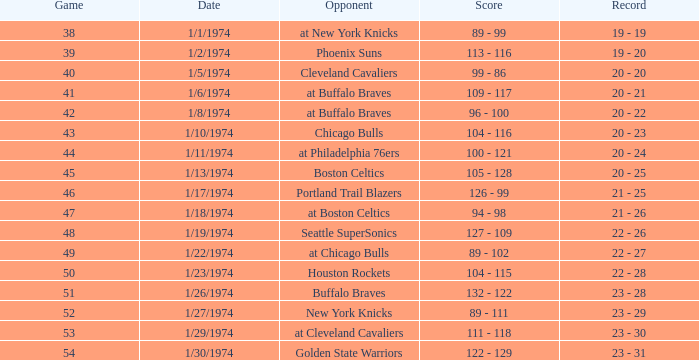What was the result on the 10th of january, 1974? 104 - 116. 